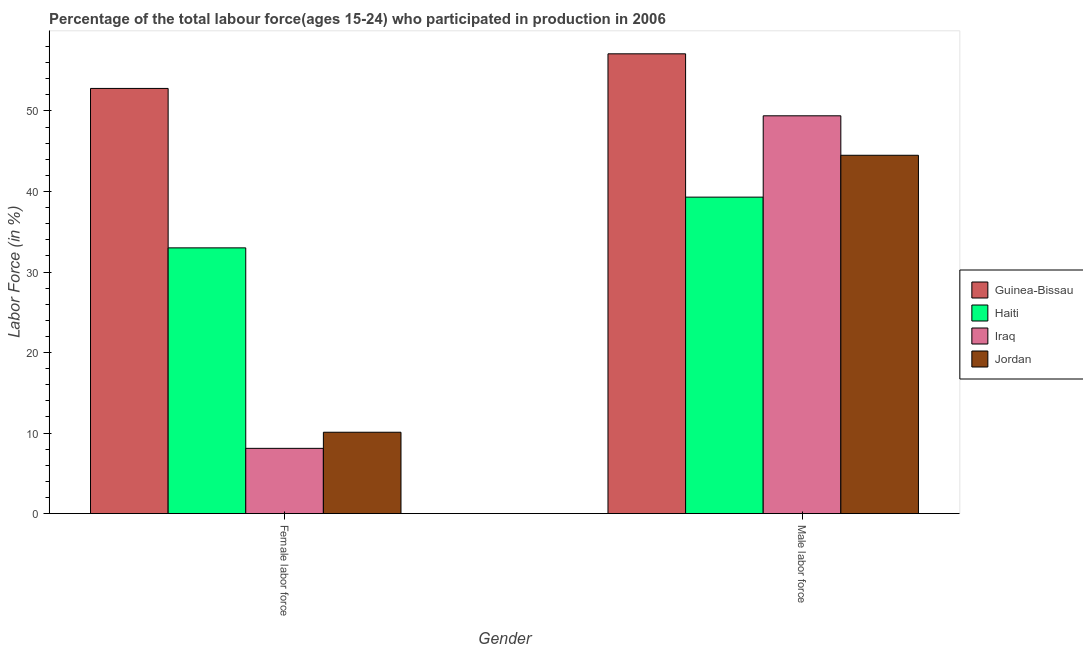How many different coloured bars are there?
Your response must be concise. 4. How many groups of bars are there?
Offer a very short reply. 2. Are the number of bars on each tick of the X-axis equal?
Give a very brief answer. Yes. How many bars are there on the 1st tick from the right?
Your answer should be very brief. 4. What is the label of the 1st group of bars from the left?
Provide a succinct answer. Female labor force. What is the percentage of male labour force in Iraq?
Offer a very short reply. 49.4. Across all countries, what is the maximum percentage of female labor force?
Provide a short and direct response. 52.8. Across all countries, what is the minimum percentage of female labor force?
Give a very brief answer. 8.1. In which country was the percentage of male labour force maximum?
Your response must be concise. Guinea-Bissau. In which country was the percentage of male labour force minimum?
Make the answer very short. Haiti. What is the total percentage of female labor force in the graph?
Provide a short and direct response. 104. What is the difference between the percentage of female labor force in Jordan and that in Guinea-Bissau?
Make the answer very short. -42.7. What is the difference between the percentage of female labor force in Haiti and the percentage of male labour force in Iraq?
Ensure brevity in your answer.  -16.4. What is the average percentage of male labour force per country?
Make the answer very short. 47.57. What is the difference between the percentage of male labour force and percentage of female labor force in Haiti?
Your answer should be very brief. 6.3. What is the ratio of the percentage of male labour force in Haiti to that in Iraq?
Give a very brief answer. 0.8. Is the percentage of female labor force in Haiti less than that in Iraq?
Provide a succinct answer. No. In how many countries, is the percentage of male labour force greater than the average percentage of male labour force taken over all countries?
Provide a short and direct response. 2. What does the 2nd bar from the left in Male labor force represents?
Provide a short and direct response. Haiti. What does the 2nd bar from the right in Male labor force represents?
Offer a very short reply. Iraq. Are all the bars in the graph horizontal?
Make the answer very short. No. Where does the legend appear in the graph?
Make the answer very short. Center right. What is the title of the graph?
Your response must be concise. Percentage of the total labour force(ages 15-24) who participated in production in 2006. What is the Labor Force (in %) of Guinea-Bissau in Female labor force?
Make the answer very short. 52.8. What is the Labor Force (in %) in Haiti in Female labor force?
Provide a short and direct response. 33. What is the Labor Force (in %) in Iraq in Female labor force?
Keep it short and to the point. 8.1. What is the Labor Force (in %) in Jordan in Female labor force?
Provide a succinct answer. 10.1. What is the Labor Force (in %) of Guinea-Bissau in Male labor force?
Your response must be concise. 57.1. What is the Labor Force (in %) in Haiti in Male labor force?
Provide a succinct answer. 39.3. What is the Labor Force (in %) in Iraq in Male labor force?
Offer a terse response. 49.4. What is the Labor Force (in %) of Jordan in Male labor force?
Ensure brevity in your answer.  44.5. Across all Gender, what is the maximum Labor Force (in %) of Guinea-Bissau?
Ensure brevity in your answer.  57.1. Across all Gender, what is the maximum Labor Force (in %) of Haiti?
Ensure brevity in your answer.  39.3. Across all Gender, what is the maximum Labor Force (in %) in Iraq?
Make the answer very short. 49.4. Across all Gender, what is the maximum Labor Force (in %) in Jordan?
Your answer should be compact. 44.5. Across all Gender, what is the minimum Labor Force (in %) of Guinea-Bissau?
Offer a terse response. 52.8. Across all Gender, what is the minimum Labor Force (in %) of Iraq?
Offer a terse response. 8.1. Across all Gender, what is the minimum Labor Force (in %) in Jordan?
Provide a short and direct response. 10.1. What is the total Labor Force (in %) of Guinea-Bissau in the graph?
Provide a succinct answer. 109.9. What is the total Labor Force (in %) of Haiti in the graph?
Provide a succinct answer. 72.3. What is the total Labor Force (in %) of Iraq in the graph?
Your response must be concise. 57.5. What is the total Labor Force (in %) of Jordan in the graph?
Make the answer very short. 54.6. What is the difference between the Labor Force (in %) of Guinea-Bissau in Female labor force and that in Male labor force?
Keep it short and to the point. -4.3. What is the difference between the Labor Force (in %) in Haiti in Female labor force and that in Male labor force?
Offer a terse response. -6.3. What is the difference between the Labor Force (in %) of Iraq in Female labor force and that in Male labor force?
Offer a very short reply. -41.3. What is the difference between the Labor Force (in %) in Jordan in Female labor force and that in Male labor force?
Your response must be concise. -34.4. What is the difference between the Labor Force (in %) of Guinea-Bissau in Female labor force and the Labor Force (in %) of Haiti in Male labor force?
Ensure brevity in your answer.  13.5. What is the difference between the Labor Force (in %) in Guinea-Bissau in Female labor force and the Labor Force (in %) in Iraq in Male labor force?
Your response must be concise. 3.4. What is the difference between the Labor Force (in %) of Haiti in Female labor force and the Labor Force (in %) of Iraq in Male labor force?
Provide a succinct answer. -16.4. What is the difference between the Labor Force (in %) in Haiti in Female labor force and the Labor Force (in %) in Jordan in Male labor force?
Your response must be concise. -11.5. What is the difference between the Labor Force (in %) in Iraq in Female labor force and the Labor Force (in %) in Jordan in Male labor force?
Give a very brief answer. -36.4. What is the average Labor Force (in %) of Guinea-Bissau per Gender?
Your answer should be compact. 54.95. What is the average Labor Force (in %) of Haiti per Gender?
Ensure brevity in your answer.  36.15. What is the average Labor Force (in %) in Iraq per Gender?
Your answer should be compact. 28.75. What is the average Labor Force (in %) of Jordan per Gender?
Make the answer very short. 27.3. What is the difference between the Labor Force (in %) in Guinea-Bissau and Labor Force (in %) in Haiti in Female labor force?
Provide a succinct answer. 19.8. What is the difference between the Labor Force (in %) in Guinea-Bissau and Labor Force (in %) in Iraq in Female labor force?
Your answer should be compact. 44.7. What is the difference between the Labor Force (in %) in Guinea-Bissau and Labor Force (in %) in Jordan in Female labor force?
Ensure brevity in your answer.  42.7. What is the difference between the Labor Force (in %) in Haiti and Labor Force (in %) in Iraq in Female labor force?
Ensure brevity in your answer.  24.9. What is the difference between the Labor Force (in %) in Haiti and Labor Force (in %) in Jordan in Female labor force?
Provide a succinct answer. 22.9. What is the difference between the Labor Force (in %) of Guinea-Bissau and Labor Force (in %) of Iraq in Male labor force?
Offer a terse response. 7.7. What is the difference between the Labor Force (in %) of Guinea-Bissau and Labor Force (in %) of Jordan in Male labor force?
Your answer should be very brief. 12.6. What is the difference between the Labor Force (in %) in Haiti and Labor Force (in %) in Iraq in Male labor force?
Ensure brevity in your answer.  -10.1. What is the difference between the Labor Force (in %) in Haiti and Labor Force (in %) in Jordan in Male labor force?
Provide a succinct answer. -5.2. What is the ratio of the Labor Force (in %) of Guinea-Bissau in Female labor force to that in Male labor force?
Offer a very short reply. 0.92. What is the ratio of the Labor Force (in %) in Haiti in Female labor force to that in Male labor force?
Your answer should be compact. 0.84. What is the ratio of the Labor Force (in %) in Iraq in Female labor force to that in Male labor force?
Your answer should be compact. 0.16. What is the ratio of the Labor Force (in %) of Jordan in Female labor force to that in Male labor force?
Ensure brevity in your answer.  0.23. What is the difference between the highest and the second highest Labor Force (in %) of Haiti?
Ensure brevity in your answer.  6.3. What is the difference between the highest and the second highest Labor Force (in %) in Iraq?
Offer a very short reply. 41.3. What is the difference between the highest and the second highest Labor Force (in %) of Jordan?
Offer a terse response. 34.4. What is the difference between the highest and the lowest Labor Force (in %) of Haiti?
Make the answer very short. 6.3. What is the difference between the highest and the lowest Labor Force (in %) in Iraq?
Your answer should be very brief. 41.3. What is the difference between the highest and the lowest Labor Force (in %) of Jordan?
Ensure brevity in your answer.  34.4. 